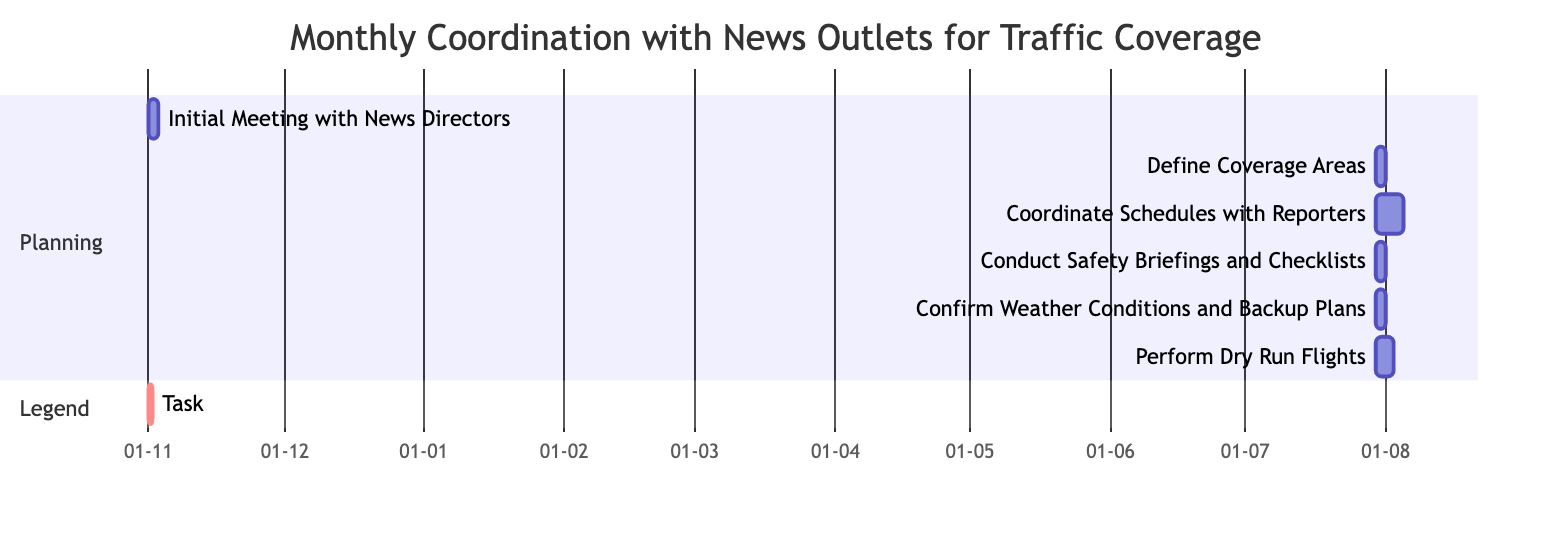What is the duration of the "Initial Meeting with News Directors"? The duration for the "Initial Meeting with News Directors" task is stated as 2 days in the chart.
Answer: 2 days What follows "Confirm Weather Conditions and Backup Plans" in the timeline? The task that follows "Confirm Weather Conditions and Backup Plans" is "Perform Dry Run Flights," which is shown as succeeding it in the timeline.
Answer: Perform Dry Run Flights How many tasks are there in total in the Gantt chart? There are 6 tasks listed in the Gantt chart, which can be counted directly off the tasks enumerated.
Answer: 6 Which task starts on November 15th? "Perform Dry Run Flights" is the task that starts on November 15th based on the start dates provided for each task in the diagram.
Answer: Perform Dry Run Flights What is the dependency for "Conduct Safety Briefings and Checklists"? The dependency for "Conduct Safety Briefings and Checklists" is the task "Coordinate Schedules with Reporters," which is clearly marked as required before starting this task.
Answer: Coordinate Schedules with Reporters What is the maximum duration for any task in the chart? The longest task in the chart is "Coordinate Schedules with Reporters," with a duration of 6 days noted in the chart.
Answer: 6 days Which task has no dependencies? The "Initial Meeting with News Directors" is the only task that has no dependencies, as indicated by its listing in the chart.
Answer: Initial Meeting with News Directors How many days are allocated for "Confirm Weather Conditions and Backup Plans"? The task "Confirm Weather Conditions and Backup Plans" is allocated 2 days as indicated in the Gantt chart for each task.
Answer: 2 days What can you infer about the sequence of tasks? The sequence of tasks indicates a linear progression where each task connects to the next based on its completion, forming a clear flow from start to finish.
Answer: Linear progression 